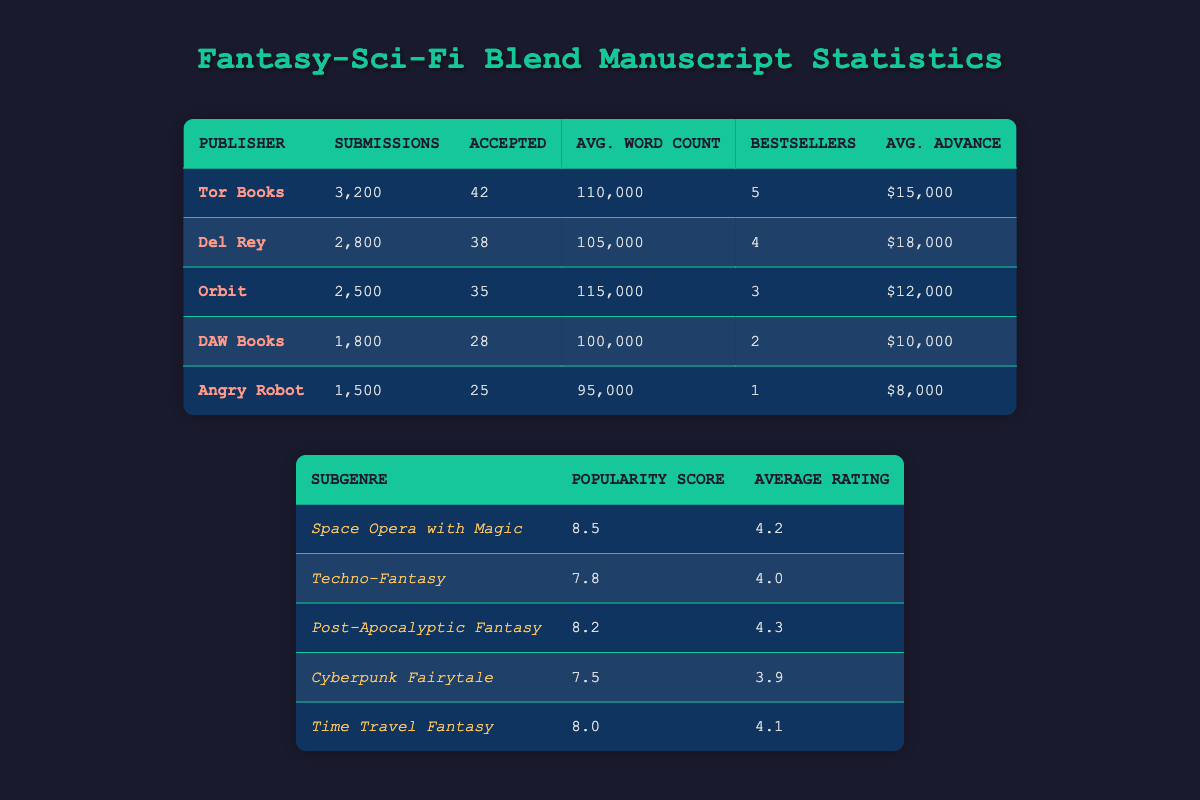What is the average word count for manuscripts accepted by Del Rey? The table shows that Del Rey has an average word count of 105,000 for accepted manuscripts.
Answer: 105,000 Which publisher has the highest average advance for fantasy-sci-fi blend manuscripts? According to the table, Del Rey offers the highest average advance of $18,000 compared to the others listed.
Answer: Del Rey How many total accepted manuscripts do Tor Books and Orbit have combined? Tor Books has 42 accepted manuscripts and Orbit has 35. Adding these together gives 42 + 35 = 77 accepted manuscripts.
Answer: 77 Is it true that Angry Robot accepted more manuscripts than DAW Books? Angry Robot accepted 25 manuscripts, while DAW Books accepted 28. Thus, the statement is false.
Answer: No What is the popularity score for Space Opera with Magic, and how does it compare to Time Travel Fantasy? Space Opera with Magic has a popularity score of 8.5, while Time Travel Fantasy has a score of 8.0. Space Opera with Magic is more popular.
Answer: 8.5 What is the difference in the average advance between Tor Books and DAW Books? Tor Books offers an average advance of $15,000, and DAW Books offers $10,000. The difference is $15,000 - $10,000 = $5,000.
Answer: $5,000 Which publisher has the least number of fantasy-sci-fi blend submissions? The table shows that Angry Robot has the least number of submissions, with 1,500.
Answer: Angry Robot How many bestsellers did Orbit have in the last year? Orbit had 3 bestsellers in the last year, as stated in the table.
Answer: 3 Which subgenre has the highest average rating? The table indicates that Post-Apocalyptic Fantasy has the highest average rating of 4.3 among the subgenres listed.
Answer: 4.3 